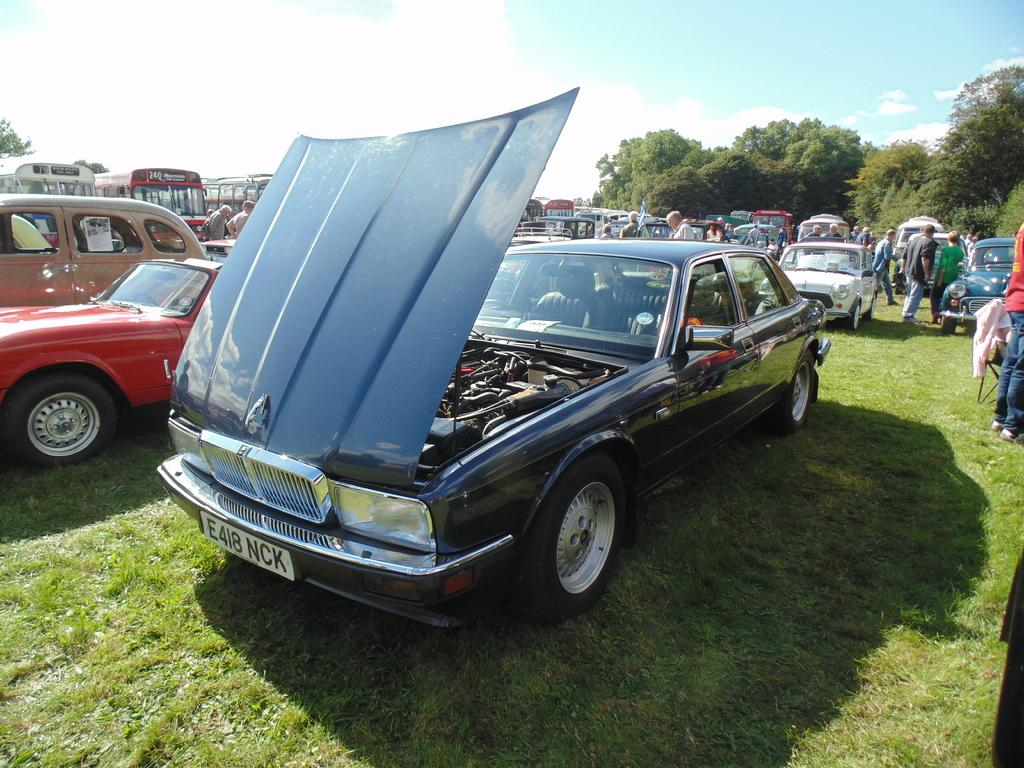What types of vehicles are in the center of the image? There are many cars and buses in the center of the image. What is located at the bottom of the image? There is grass at the bottom of the image. What can be seen in the background of the image? There are trees in the background of the image. How many beads are scattered on the grass in the image? There are no beads present in the image. Are there any kittens playing in the grass in the image? There are no kittens present in the image. 